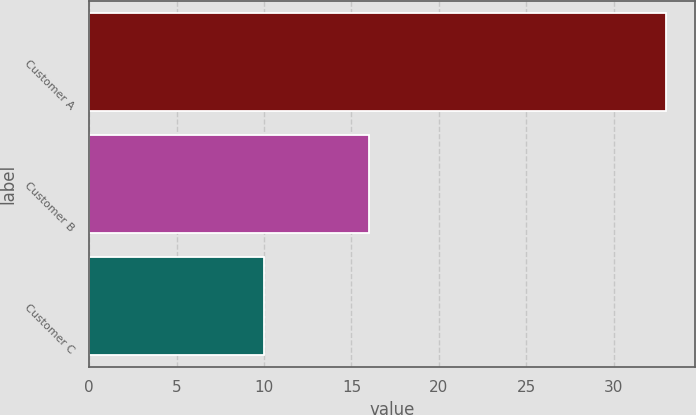Convert chart to OTSL. <chart><loc_0><loc_0><loc_500><loc_500><bar_chart><fcel>Customer A<fcel>Customer B<fcel>Customer C<nl><fcel>33<fcel>16<fcel>10<nl></chart> 